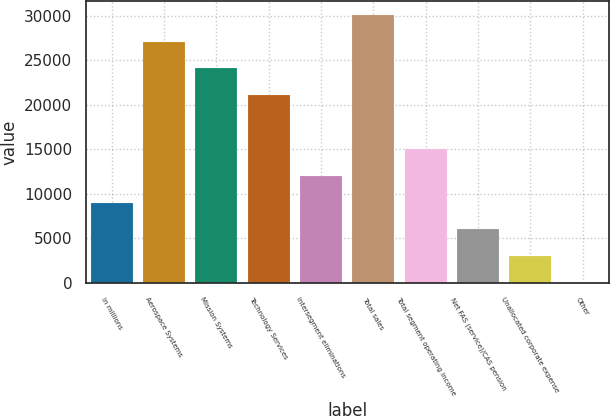Convert chart to OTSL. <chart><loc_0><loc_0><loc_500><loc_500><bar_chart><fcel>in millions<fcel>Aerospace Systems<fcel>Mission Systems<fcel>Technology Services<fcel>Intersegment eliminations<fcel>Total sales<fcel>Total segment operating income<fcel>Net FAS (service)/CAS pension<fcel>Unallocated corporate expense<fcel>Other<nl><fcel>9030.6<fcel>27085.8<fcel>24076.6<fcel>21067.4<fcel>12039.8<fcel>30095<fcel>15049<fcel>6021.4<fcel>3012.2<fcel>3<nl></chart> 